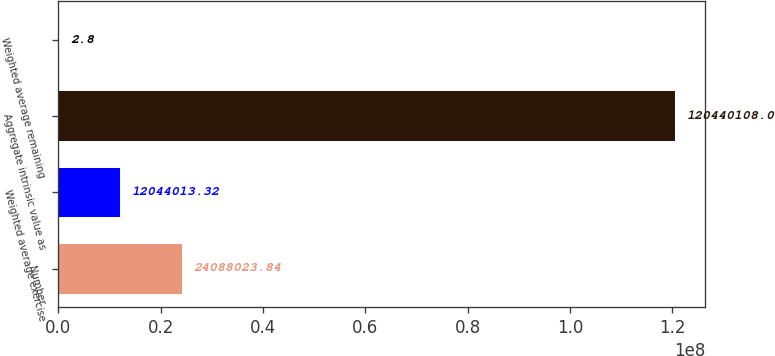Convert chart. <chart><loc_0><loc_0><loc_500><loc_500><bar_chart><fcel>Number<fcel>Weighted average exercise<fcel>Aggregate intrinsic value as<fcel>Weighted average remaining<nl><fcel>2.4088e+07<fcel>1.2044e+07<fcel>1.2044e+08<fcel>2.8<nl></chart> 